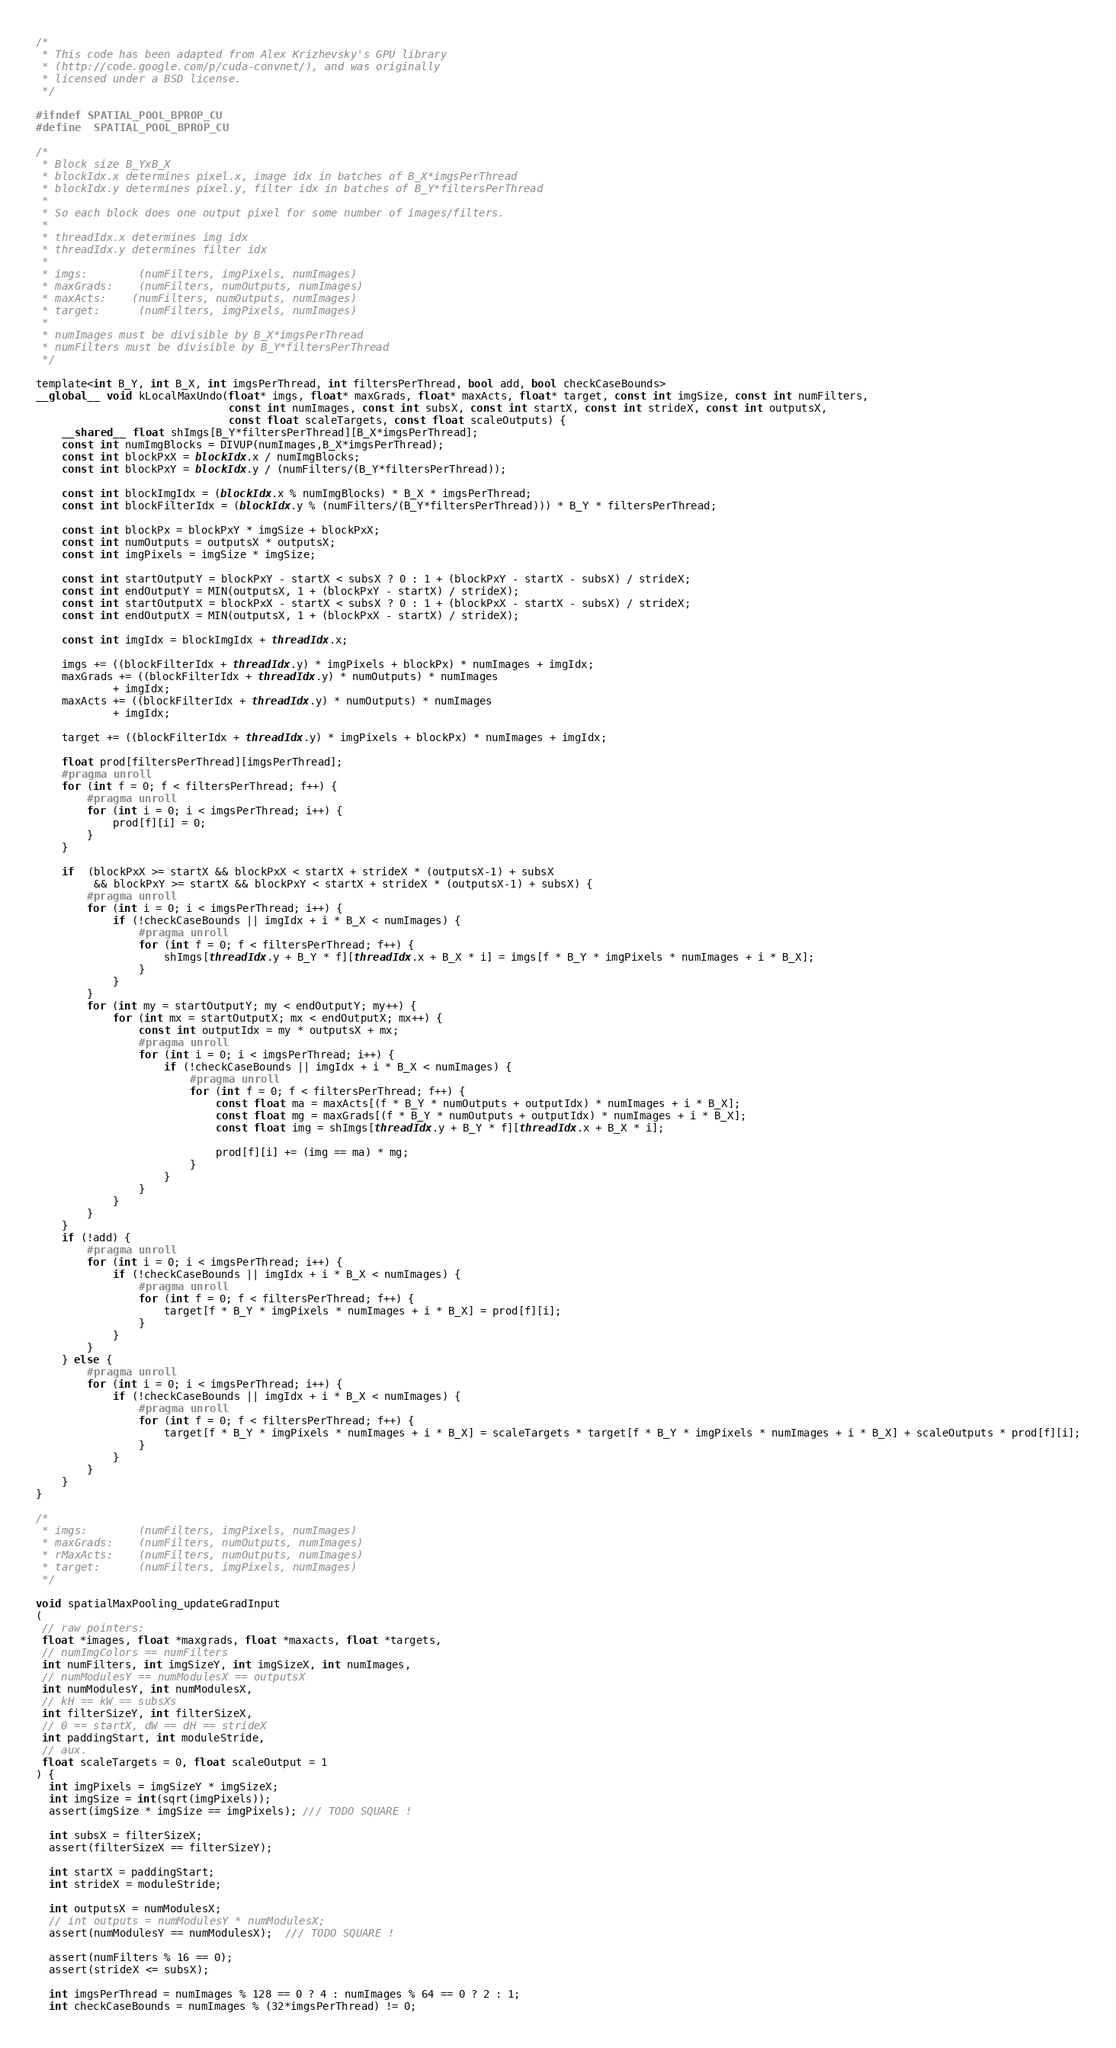<code> <loc_0><loc_0><loc_500><loc_500><_Cuda_>/* 
 * This code has been adapted from Alex Krizhevsky's GPU library
 * (http://code.google.com/p/cuda-convnet/), and was originally
 * licensed under a BSD license.
 */

#ifndef SPATIAL_POOL_BPROP_CU
#define	SPATIAL_POOL_BPROP_CU

/*
 * Block size B_YxB_X
 * blockIdx.x determines pixel.x, image idx in batches of B_X*imgsPerThread
 * blockIdx.y determines pixel.y, filter idx in batches of B_Y*filtersPerThread
 * 
 * So each block does one output pixel for some number of images/filters.
 * 
 * threadIdx.x determines img idx
 * threadIdx.y determines filter idx
 * 
 * imgs:        (numFilters, imgPixels, numImages)
 * maxGrads:    (numFilters, numOutputs, numImages)
 * maxActs:    (numFilters, numOutputs, numImages)
 * target:      (numFilters, imgPixels, numImages)
 * 
 * numImages must be divisible by B_X*imgsPerThread
 * numFilters must be divisible by B_Y*filtersPerThread
 */

template<int B_Y, int B_X, int imgsPerThread, int filtersPerThread, bool add, bool checkCaseBounds>
__global__ void kLocalMaxUndo(float* imgs, float* maxGrads, float* maxActs, float* target, const int imgSize, const int numFilters,
                              const int numImages, const int subsX, const int startX, const int strideX, const int outputsX,
                              const float scaleTargets, const float scaleOutputs) {
    __shared__ float shImgs[B_Y*filtersPerThread][B_X*imgsPerThread];
    const int numImgBlocks = DIVUP(numImages,B_X*imgsPerThread);
    const int blockPxX = blockIdx.x / numImgBlocks;
    const int blockPxY = blockIdx.y / (numFilters/(B_Y*filtersPerThread));
    
    const int blockImgIdx = (blockIdx.x % numImgBlocks) * B_X * imgsPerThread;
    const int blockFilterIdx = (blockIdx.y % (numFilters/(B_Y*filtersPerThread))) * B_Y * filtersPerThread;
    
    const int blockPx = blockPxY * imgSize + blockPxX;
    const int numOutputs = outputsX * outputsX;
    const int imgPixels = imgSize * imgSize;

    const int startOutputY = blockPxY - startX < subsX ? 0 : 1 + (blockPxY - startX - subsX) / strideX;
    const int endOutputY = MIN(outputsX, 1 + (blockPxY - startX) / strideX);
    const int startOutputX = blockPxX - startX < subsX ? 0 : 1 + (blockPxX - startX - subsX) / strideX;
    const int endOutputX = MIN(outputsX, 1 + (blockPxX - startX) / strideX);
    
    const int imgIdx = blockImgIdx + threadIdx.x;
    
    imgs += ((blockFilterIdx + threadIdx.y) * imgPixels + blockPx) * numImages + imgIdx;
    maxGrads += ((blockFilterIdx + threadIdx.y) * numOutputs) * numImages 
            + imgIdx;
    maxActs += ((blockFilterIdx + threadIdx.y) * numOutputs) * numImages 
            + imgIdx;
    
    target += ((blockFilterIdx + threadIdx.y) * imgPixels + blockPx) * numImages + imgIdx;
    
    float prod[filtersPerThread][imgsPerThread];
    #pragma unroll
    for (int f = 0; f < filtersPerThread; f++) {
        #pragma unroll
        for (int i = 0; i < imgsPerThread; i++) {
            prod[f][i] = 0;
        }
    }
    
    if  (blockPxX >= startX && blockPxX < startX + strideX * (outputsX-1) + subsX 
         && blockPxY >= startX && blockPxY < startX + strideX * (outputsX-1) + subsX) {
        #pragma unroll
        for (int i = 0; i < imgsPerThread; i++) {
            if (!checkCaseBounds || imgIdx + i * B_X < numImages) {
                #pragma unroll
                for (int f = 0; f < filtersPerThread; f++) {
                    shImgs[threadIdx.y + B_Y * f][threadIdx.x + B_X * i] = imgs[f * B_Y * imgPixels * numImages + i * B_X];
                }
            }
        }
        for (int my = startOutputY; my < endOutputY; my++) {
            for (int mx = startOutputX; mx < endOutputX; mx++) {
                const int outputIdx = my * outputsX + mx;
                #pragma unroll
                for (int i = 0; i < imgsPerThread; i++) {
                    if (!checkCaseBounds || imgIdx + i * B_X < numImages) {
                        #pragma unroll
                        for (int f = 0; f < filtersPerThread; f++) {
                            const float ma = maxActs[(f * B_Y * numOutputs + outputIdx) * numImages + i * B_X]; 
                            const float mg = maxGrads[(f * B_Y * numOutputs + outputIdx) * numImages + i * B_X];
                            const float img = shImgs[threadIdx.y + B_Y * f][threadIdx.x + B_X * i];

                            prod[f][i] += (img == ma) * mg;
                        }
                    }
                }
            }
        }
    }
    if (!add) {
        #pragma unroll
        for (int i = 0; i < imgsPerThread; i++) {
            if (!checkCaseBounds || imgIdx + i * B_X < numImages) {
                #pragma unroll
                for (int f = 0; f < filtersPerThread; f++) {
                    target[f * B_Y * imgPixels * numImages + i * B_X] = prod[f][i];
                }
            }
        }
    } else {
        #pragma unroll
        for (int i = 0; i < imgsPerThread; i++) {
            if (!checkCaseBounds || imgIdx + i * B_X < numImages) {
                #pragma unroll
                for (int f = 0; f < filtersPerThread; f++) {
                    target[f * B_Y * imgPixels * numImages + i * B_X] = scaleTargets * target[f * B_Y * imgPixels * numImages + i * B_X] + scaleOutputs * prod[f][i];
                }
            }
        }
    }
}

/*
 * imgs:        (numFilters, imgPixels, numImages)
 * maxGrads:    (numFilters, numOutputs, numImages)
 * rMaxActs:    (numFilters, numOutputs, numImages)
 * target:      (numFilters, imgPixels, numImages)
 */

void spatialMaxPooling_updateGradInput
(
 // raw pointers:
 float *images, float *maxgrads, float *maxacts, float *targets,
 // numImgColors == numFilters
 int numFilters, int imgSizeY, int imgSizeX, int numImages,
 // numModulesY == numModulesX == outputsX
 int numModulesY, int numModulesX, 
 // kH == kW == subsXs
 int filterSizeY, int filterSizeX, 
 // 0 == startX, dW == dH == strideX
 int paddingStart, int moduleStride, 
 // aux.
 float scaleTargets = 0, float scaleOutput = 1
) { 
  int imgPixels = imgSizeY * imgSizeX;
  int imgSize = int(sqrt(imgPixels)); 
  assert(imgSize * imgSize == imgPixels); /// TODO SQUARE !

  int subsX = filterSizeX;
  assert(filterSizeX == filterSizeY);
  
  int startX = paddingStart;
  int strideX = moduleStride;

  int outputsX = numModulesX;
  // int outputs = numModulesY * numModulesX;
  assert(numModulesY == numModulesX);  /// TODO SQUARE !

  assert(numFilters % 16 == 0);
  assert(strideX <= subsX);
    
  int imgsPerThread = numImages % 128 == 0 ? 4 : numImages % 64 == 0 ? 2 : 1;
  int checkCaseBounds = numImages % (32*imgsPerThread) != 0;</code> 